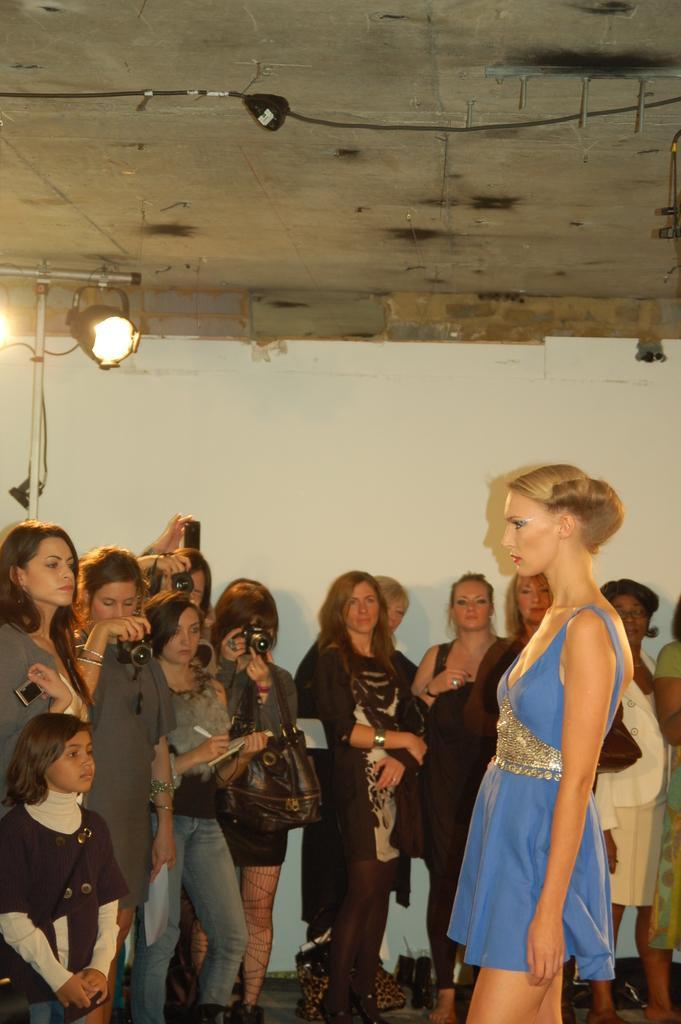Describe this image in one or two sentences. in this image I can see there are few women standing and some of them are holding the camera and taking the picture of a woman wearing a blue color dress ,standing in front of them. And at the top I can see a white color wall and a light attached to the wall 